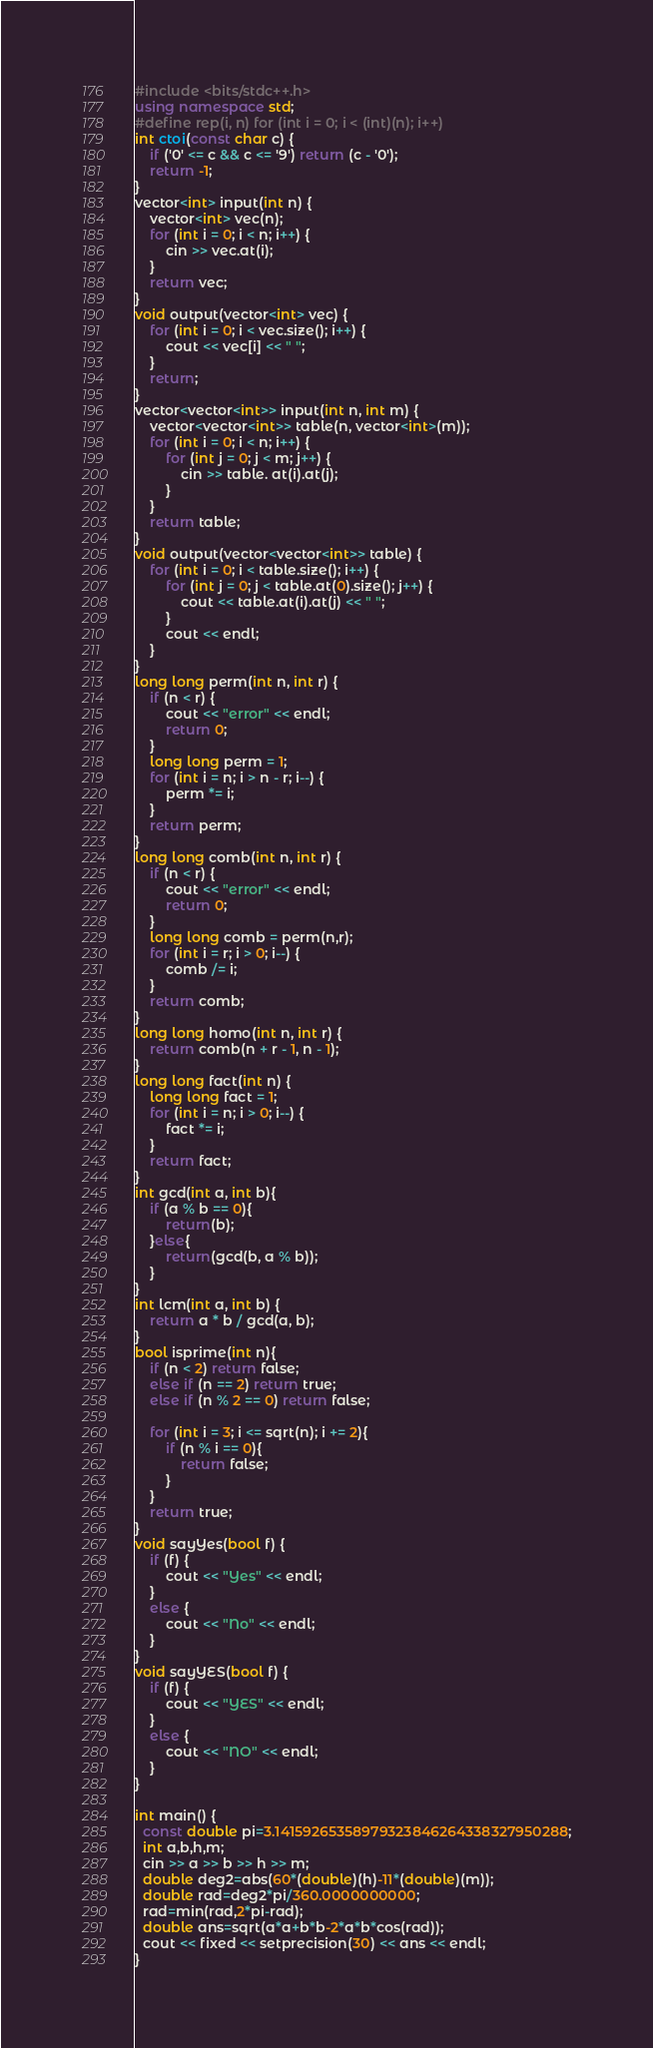Convert code to text. <code><loc_0><loc_0><loc_500><loc_500><_C++_>#include <bits/stdc++.h>
using namespace std;
#define rep(i, n) for (int i = 0; i < (int)(n); i++)
int ctoi(const char c) {
    if ('0' <= c && c <= '9') return (c - '0');
    return -1;
}
vector<int> input(int n) {
    vector<int> vec(n);
    for (int i = 0; i < n; i++) {
        cin >> vec.at(i);
    }
    return vec;
}
void output(vector<int> vec) {
    for (int i = 0; i < vec.size(); i++) {
        cout << vec[i] << " ";
    }
    return;
}
vector<vector<int>> input(int n, int m) {
    vector<vector<int>> table(n, vector<int>(m));
    for (int i = 0; i < n; i++) {
        for (int j = 0; j < m; j++) {
            cin >> table. at(i).at(j);
        }
    }
    return table;
}
void output(vector<vector<int>> table) {
    for (int i = 0; i < table.size(); i++) {
        for (int j = 0; j < table.at(0).size(); j++) {
            cout << table.at(i).at(j) << " ";
        }
        cout << endl;
    }
}
long long perm(int n, int r) {
    if (n < r) {
        cout << "error" << endl;
        return 0;
    }
    long long perm = 1;
    for (int i = n; i > n - r; i--) {
        perm *= i;
    }
    return perm;
}
long long comb(int n, int r) {
    if (n < r) {
        cout << "error" << endl;
        return 0;
    }
    long long comb = perm(n,r);
    for (int i = r; i > 0; i--) {
        comb /= i;
    }
    return comb;
}
long long homo(int n, int r) {
    return comb(n + r - 1, n - 1);
}
long long fact(int n) {
    long long fact = 1;
    for (int i = n; i > 0; i--) {
        fact *= i;
    }
    return fact;
}
int gcd(int a, int b){
    if (a % b == 0){
        return(b);
    }else{
        return(gcd(b, a % b));
    }
}
int lcm(int a, int b) {
    return a * b / gcd(a, b);
}
bool isprime(int n){
    if (n < 2) return false;
    else if (n == 2) return true;
    else if (n % 2 == 0) return false;

    for (int i = 3; i <= sqrt(n); i += 2){
        if (n % i == 0){
            return false;
        }
    }
    return true;
}
void sayYes(bool f) {
    if (f) {
        cout << "Yes" << endl;
    }
    else {
        cout << "No" << endl;
    }
}
void sayYES(bool f) {
    if (f) {
        cout << "YES" << endl;
    }
    else {
        cout << "NO" << endl;
    }
}

int main() {
  const double pi=3.14159265358979323846264338327950288;
  int a,b,h,m;
  cin >> a >> b >> h >> m;
  double deg2=abs(60*(double)(h)-11*(double)(m));
  double rad=deg2*pi/360.0000000000;
  rad=min(rad,2*pi-rad);
  double ans=sqrt(a*a+b*b-2*a*b*cos(rad));
  cout << fixed << setprecision(30) << ans << endl;
}</code> 